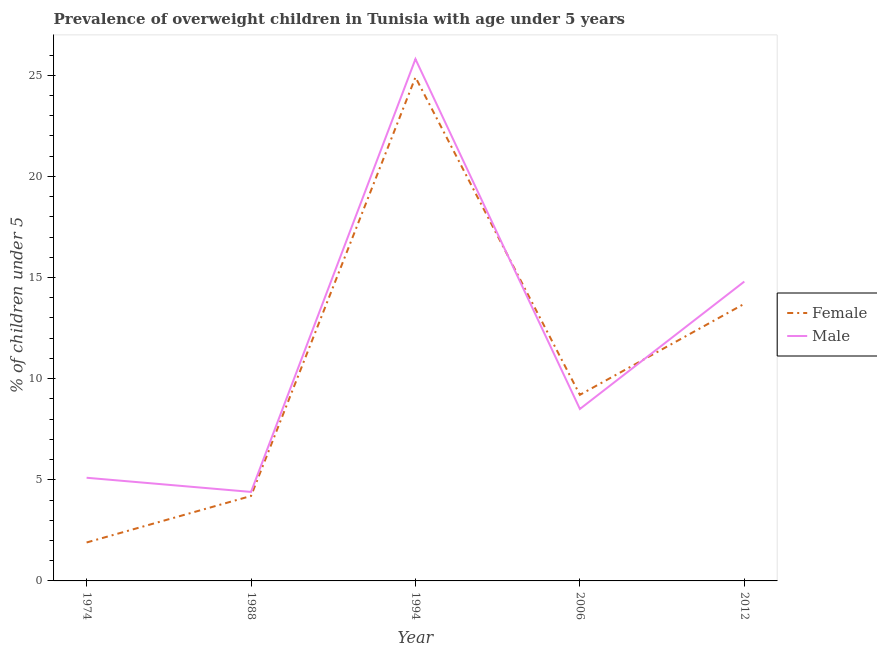How many different coloured lines are there?
Make the answer very short. 2. Does the line corresponding to percentage of obese female children intersect with the line corresponding to percentage of obese male children?
Keep it short and to the point. Yes. What is the percentage of obese male children in 1988?
Make the answer very short. 4.4. Across all years, what is the maximum percentage of obese male children?
Provide a succinct answer. 25.8. Across all years, what is the minimum percentage of obese female children?
Give a very brief answer. 1.9. What is the total percentage of obese female children in the graph?
Provide a succinct answer. 53.9. What is the difference between the percentage of obese male children in 1988 and that in 2006?
Give a very brief answer. -4.1. What is the difference between the percentage of obese male children in 1974 and the percentage of obese female children in 1988?
Provide a succinct answer. 0.9. What is the average percentage of obese male children per year?
Your answer should be very brief. 11.72. In the year 1988, what is the difference between the percentage of obese male children and percentage of obese female children?
Make the answer very short. 0.2. In how many years, is the percentage of obese female children greater than 22 %?
Keep it short and to the point. 1. What is the ratio of the percentage of obese female children in 1994 to that in 2012?
Provide a succinct answer. 1.82. What is the difference between the highest and the second highest percentage of obese female children?
Ensure brevity in your answer.  11.2. What is the difference between the highest and the lowest percentage of obese male children?
Offer a terse response. 21.4. In how many years, is the percentage of obese female children greater than the average percentage of obese female children taken over all years?
Keep it short and to the point. 2. Does the percentage of obese female children monotonically increase over the years?
Offer a terse response. No. Is the percentage of obese female children strictly greater than the percentage of obese male children over the years?
Your answer should be compact. No. How many lines are there?
Give a very brief answer. 2. How many years are there in the graph?
Give a very brief answer. 5. What is the difference between two consecutive major ticks on the Y-axis?
Give a very brief answer. 5. Are the values on the major ticks of Y-axis written in scientific E-notation?
Offer a terse response. No. Does the graph contain any zero values?
Keep it short and to the point. No. What is the title of the graph?
Make the answer very short. Prevalence of overweight children in Tunisia with age under 5 years. What is the label or title of the Y-axis?
Your response must be concise.  % of children under 5. What is the  % of children under 5 of Female in 1974?
Ensure brevity in your answer.  1.9. What is the  % of children under 5 of Male in 1974?
Offer a terse response. 5.1. What is the  % of children under 5 of Female in 1988?
Your answer should be compact. 4.2. What is the  % of children under 5 of Male in 1988?
Make the answer very short. 4.4. What is the  % of children under 5 of Female in 1994?
Keep it short and to the point. 24.9. What is the  % of children under 5 of Male in 1994?
Keep it short and to the point. 25.8. What is the  % of children under 5 in Female in 2006?
Keep it short and to the point. 9.2. What is the  % of children under 5 of Female in 2012?
Ensure brevity in your answer.  13.7. What is the  % of children under 5 in Male in 2012?
Your response must be concise. 14.8. Across all years, what is the maximum  % of children under 5 of Female?
Your response must be concise. 24.9. Across all years, what is the maximum  % of children under 5 in Male?
Provide a succinct answer. 25.8. Across all years, what is the minimum  % of children under 5 of Female?
Your answer should be compact. 1.9. Across all years, what is the minimum  % of children under 5 in Male?
Provide a succinct answer. 4.4. What is the total  % of children under 5 in Female in the graph?
Make the answer very short. 53.9. What is the total  % of children under 5 in Male in the graph?
Offer a terse response. 58.6. What is the difference between the  % of children under 5 in Male in 1974 and that in 1988?
Provide a succinct answer. 0.7. What is the difference between the  % of children under 5 of Female in 1974 and that in 1994?
Make the answer very short. -23. What is the difference between the  % of children under 5 of Male in 1974 and that in 1994?
Give a very brief answer. -20.7. What is the difference between the  % of children under 5 of Female in 1974 and that in 2006?
Your answer should be very brief. -7.3. What is the difference between the  % of children under 5 in Male in 1974 and that in 2006?
Make the answer very short. -3.4. What is the difference between the  % of children under 5 of Male in 1974 and that in 2012?
Offer a very short reply. -9.7. What is the difference between the  % of children under 5 of Female in 1988 and that in 1994?
Offer a terse response. -20.7. What is the difference between the  % of children under 5 of Male in 1988 and that in 1994?
Ensure brevity in your answer.  -21.4. What is the difference between the  % of children under 5 of Female in 1994 and that in 2006?
Make the answer very short. 15.7. What is the difference between the  % of children under 5 of Female in 1994 and that in 2012?
Your answer should be very brief. 11.2. What is the difference between the  % of children under 5 in Male in 1994 and that in 2012?
Provide a succinct answer. 11. What is the difference between the  % of children under 5 in Male in 2006 and that in 2012?
Your response must be concise. -6.3. What is the difference between the  % of children under 5 of Female in 1974 and the  % of children under 5 of Male in 1988?
Provide a succinct answer. -2.5. What is the difference between the  % of children under 5 in Female in 1974 and the  % of children under 5 in Male in 1994?
Your answer should be very brief. -23.9. What is the difference between the  % of children under 5 in Female in 1988 and the  % of children under 5 in Male in 1994?
Offer a terse response. -21.6. What is the difference between the  % of children under 5 in Female in 1994 and the  % of children under 5 in Male in 2006?
Offer a terse response. 16.4. What is the difference between the  % of children under 5 of Female in 1994 and the  % of children under 5 of Male in 2012?
Offer a very short reply. 10.1. What is the average  % of children under 5 of Female per year?
Your answer should be very brief. 10.78. What is the average  % of children under 5 of Male per year?
Offer a very short reply. 11.72. In the year 1974, what is the difference between the  % of children under 5 in Female and  % of children under 5 in Male?
Provide a short and direct response. -3.2. In the year 1988, what is the difference between the  % of children under 5 of Female and  % of children under 5 of Male?
Provide a succinct answer. -0.2. In the year 1994, what is the difference between the  % of children under 5 in Female and  % of children under 5 in Male?
Keep it short and to the point. -0.9. In the year 2006, what is the difference between the  % of children under 5 of Female and  % of children under 5 of Male?
Offer a very short reply. 0.7. In the year 2012, what is the difference between the  % of children under 5 in Female and  % of children under 5 in Male?
Offer a very short reply. -1.1. What is the ratio of the  % of children under 5 of Female in 1974 to that in 1988?
Keep it short and to the point. 0.45. What is the ratio of the  % of children under 5 of Male in 1974 to that in 1988?
Offer a terse response. 1.16. What is the ratio of the  % of children under 5 in Female in 1974 to that in 1994?
Make the answer very short. 0.08. What is the ratio of the  % of children under 5 of Male in 1974 to that in 1994?
Your answer should be very brief. 0.2. What is the ratio of the  % of children under 5 in Female in 1974 to that in 2006?
Your answer should be compact. 0.21. What is the ratio of the  % of children under 5 of Male in 1974 to that in 2006?
Your answer should be compact. 0.6. What is the ratio of the  % of children under 5 in Female in 1974 to that in 2012?
Provide a short and direct response. 0.14. What is the ratio of the  % of children under 5 of Male in 1974 to that in 2012?
Offer a terse response. 0.34. What is the ratio of the  % of children under 5 of Female in 1988 to that in 1994?
Give a very brief answer. 0.17. What is the ratio of the  % of children under 5 of Male in 1988 to that in 1994?
Give a very brief answer. 0.17. What is the ratio of the  % of children under 5 in Female in 1988 to that in 2006?
Provide a succinct answer. 0.46. What is the ratio of the  % of children under 5 in Male in 1988 to that in 2006?
Provide a succinct answer. 0.52. What is the ratio of the  % of children under 5 of Female in 1988 to that in 2012?
Ensure brevity in your answer.  0.31. What is the ratio of the  % of children under 5 in Male in 1988 to that in 2012?
Offer a very short reply. 0.3. What is the ratio of the  % of children under 5 of Female in 1994 to that in 2006?
Offer a terse response. 2.71. What is the ratio of the  % of children under 5 of Male in 1994 to that in 2006?
Your answer should be very brief. 3.04. What is the ratio of the  % of children under 5 in Female in 1994 to that in 2012?
Make the answer very short. 1.82. What is the ratio of the  % of children under 5 of Male in 1994 to that in 2012?
Provide a short and direct response. 1.74. What is the ratio of the  % of children under 5 in Female in 2006 to that in 2012?
Offer a very short reply. 0.67. What is the ratio of the  % of children under 5 of Male in 2006 to that in 2012?
Provide a succinct answer. 0.57. What is the difference between the highest and the second highest  % of children under 5 in Female?
Your response must be concise. 11.2. What is the difference between the highest and the second highest  % of children under 5 in Male?
Ensure brevity in your answer.  11. What is the difference between the highest and the lowest  % of children under 5 of Female?
Provide a succinct answer. 23. What is the difference between the highest and the lowest  % of children under 5 of Male?
Offer a very short reply. 21.4. 